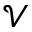<formula> <loc_0><loc_0><loc_500><loc_500>\mathcal { V }</formula> 